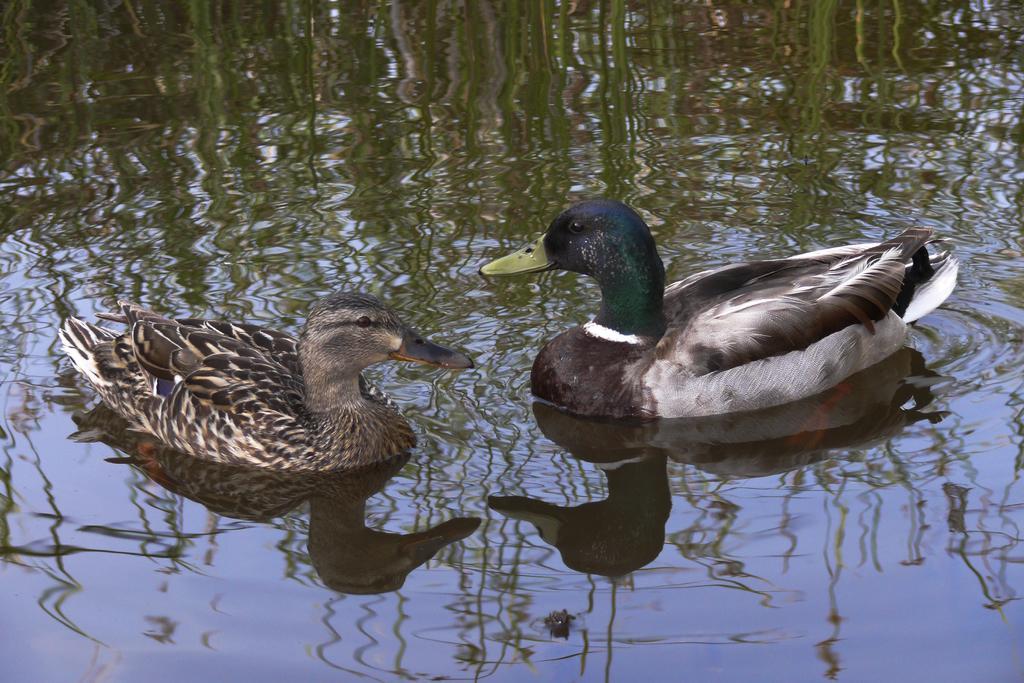Please provide a concise description of this image. In this picture we can see the reflection of green plants on the water. We can see ducks. 